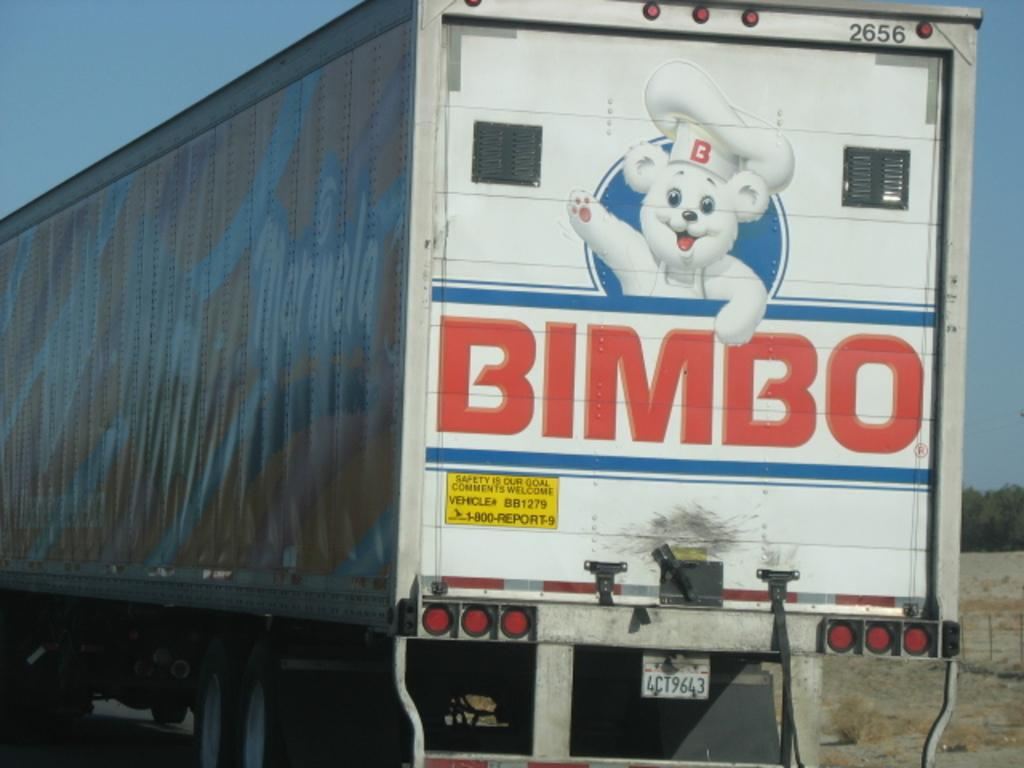What is the main subject of the image? There is a vehicle on the road in the image. Can you describe any specific features of the vehicle? The vehicle has an image and some text on it. What type of vegetation is on the right side of the image? There are trees on the right side of the image. What is visible in the background of the image? The sky is visible in the background of the image. What type of haircut does the vehicle have in the image? The vehicle does not have a haircut, as it is an inanimate object and not a living being. 